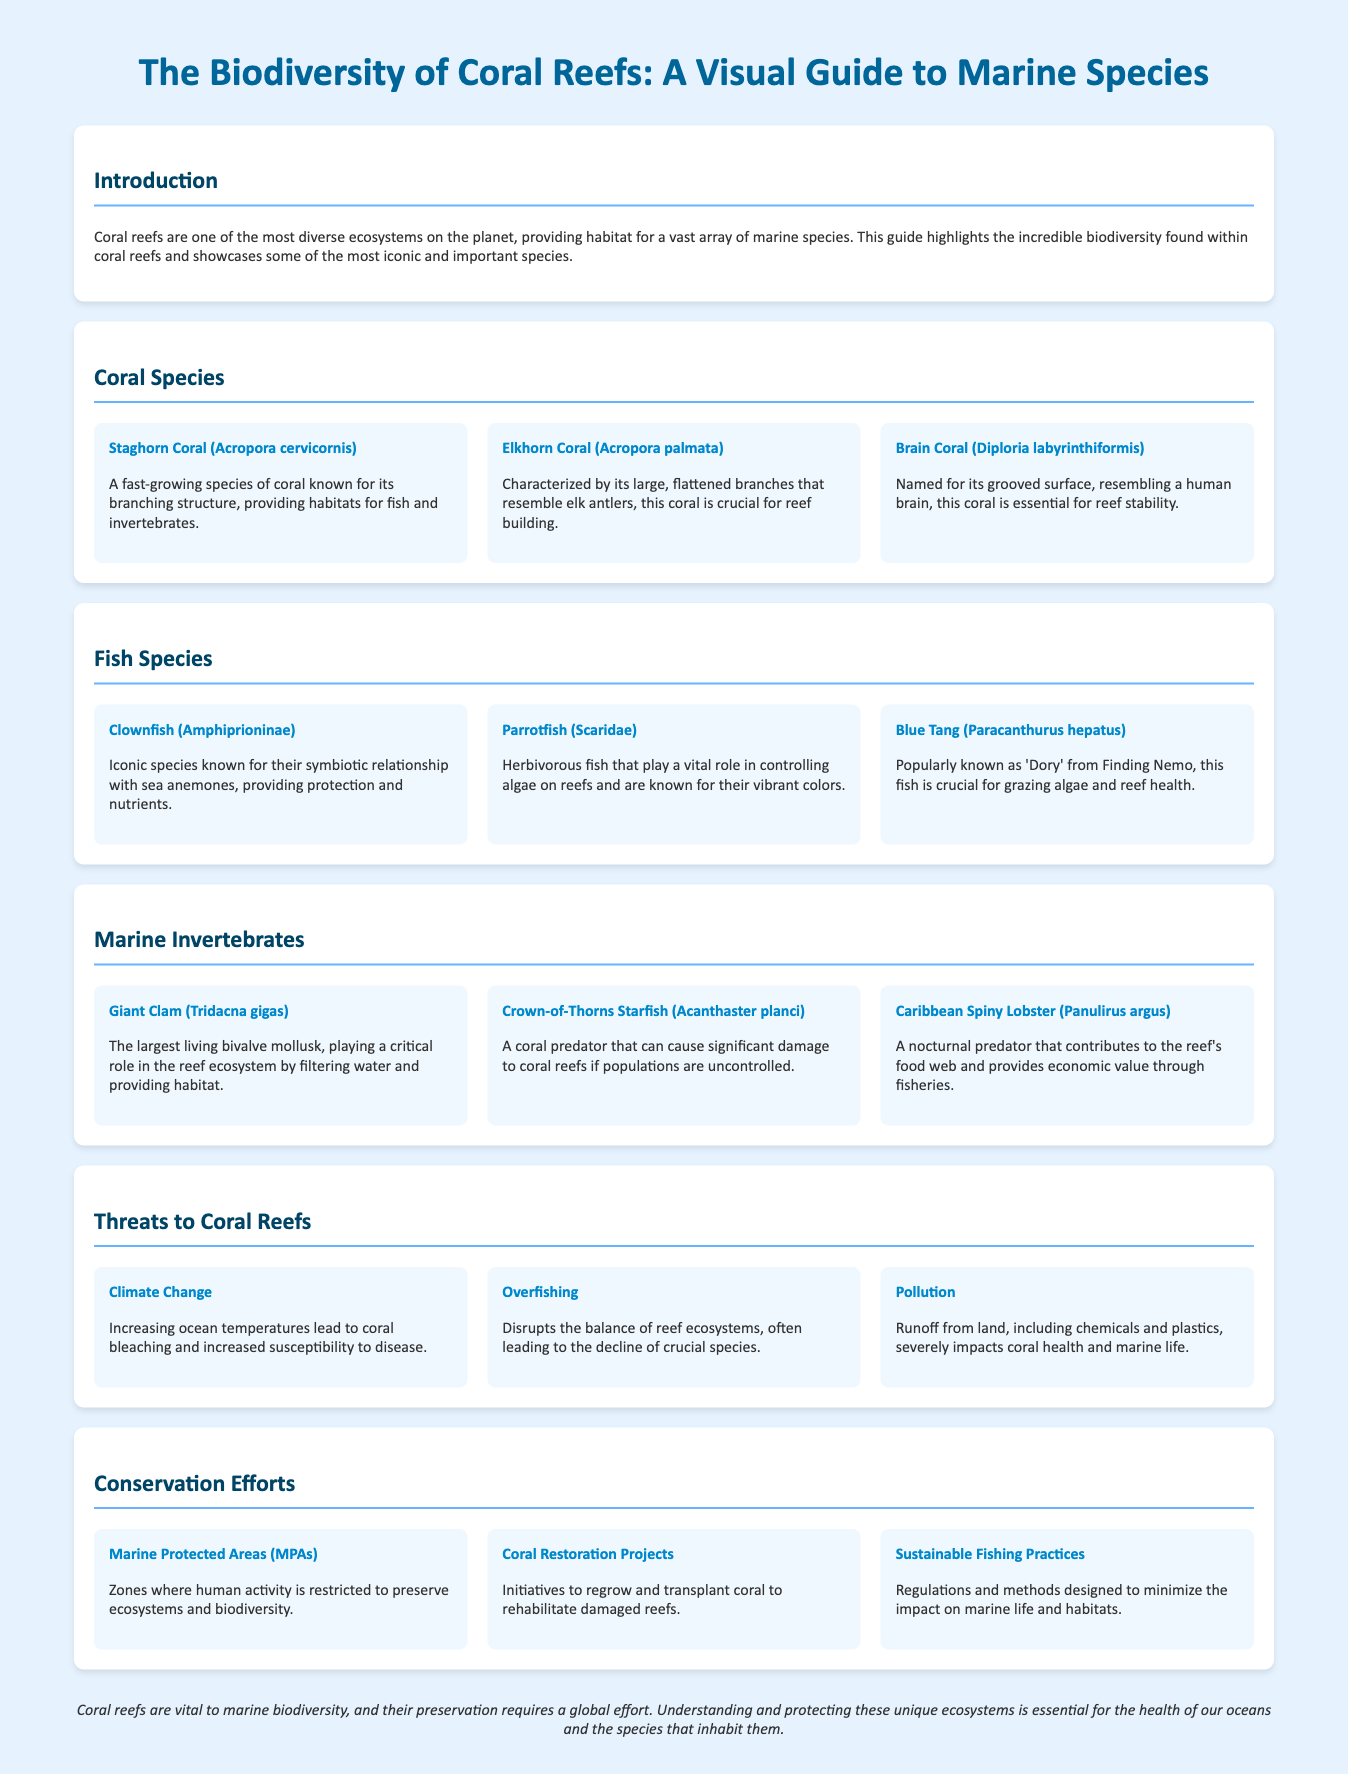What is the title of the infographic? The title is prominently displayed at the top of the document, summarizing the content about marine species and coral reefs.
Answer: The Biodiversity of Coral Reefs: A Visual Guide to Marine Species How many coral species are mentioned? The document lists three specific coral species in the "Coral Species" section.
Answer: 3 What is the role of Clownfish? The Clownfish has a known relationship providing protection and nutrients in association with another marine species.
Answer: Symbiotic relationship with sea anemones What are the three main threats to coral reefs mentioned? The document outlines three specific threats in the "Threats to Coral Reefs" section.
Answer: Climate Change, Overfishing, Pollution Which marine invertebrate is noted as the largest living bivalve mollusk? Within the "Marine Invertebrates" section, this species is highlighted for its significant size and role.
Answer: Giant Clam (Tridacna gigas) What type of conservation effort is highlighted for preserving coral reefs? The document lists various conservation strategies, with specific titles relating to marine ecosystem preservation.
Answer: Marine Protected Areas (MPAs) Why are Parrotfish important to coral reefs? Their described role in the document indicates a key function they perform within the reef ecosystem.
Answer: Controlling algae on reefs What does the conclusion emphasize? The concluding section of the document summarizes the importance of coral reefs and the need for global efforts.
Answer: Preservation requires a global effort 